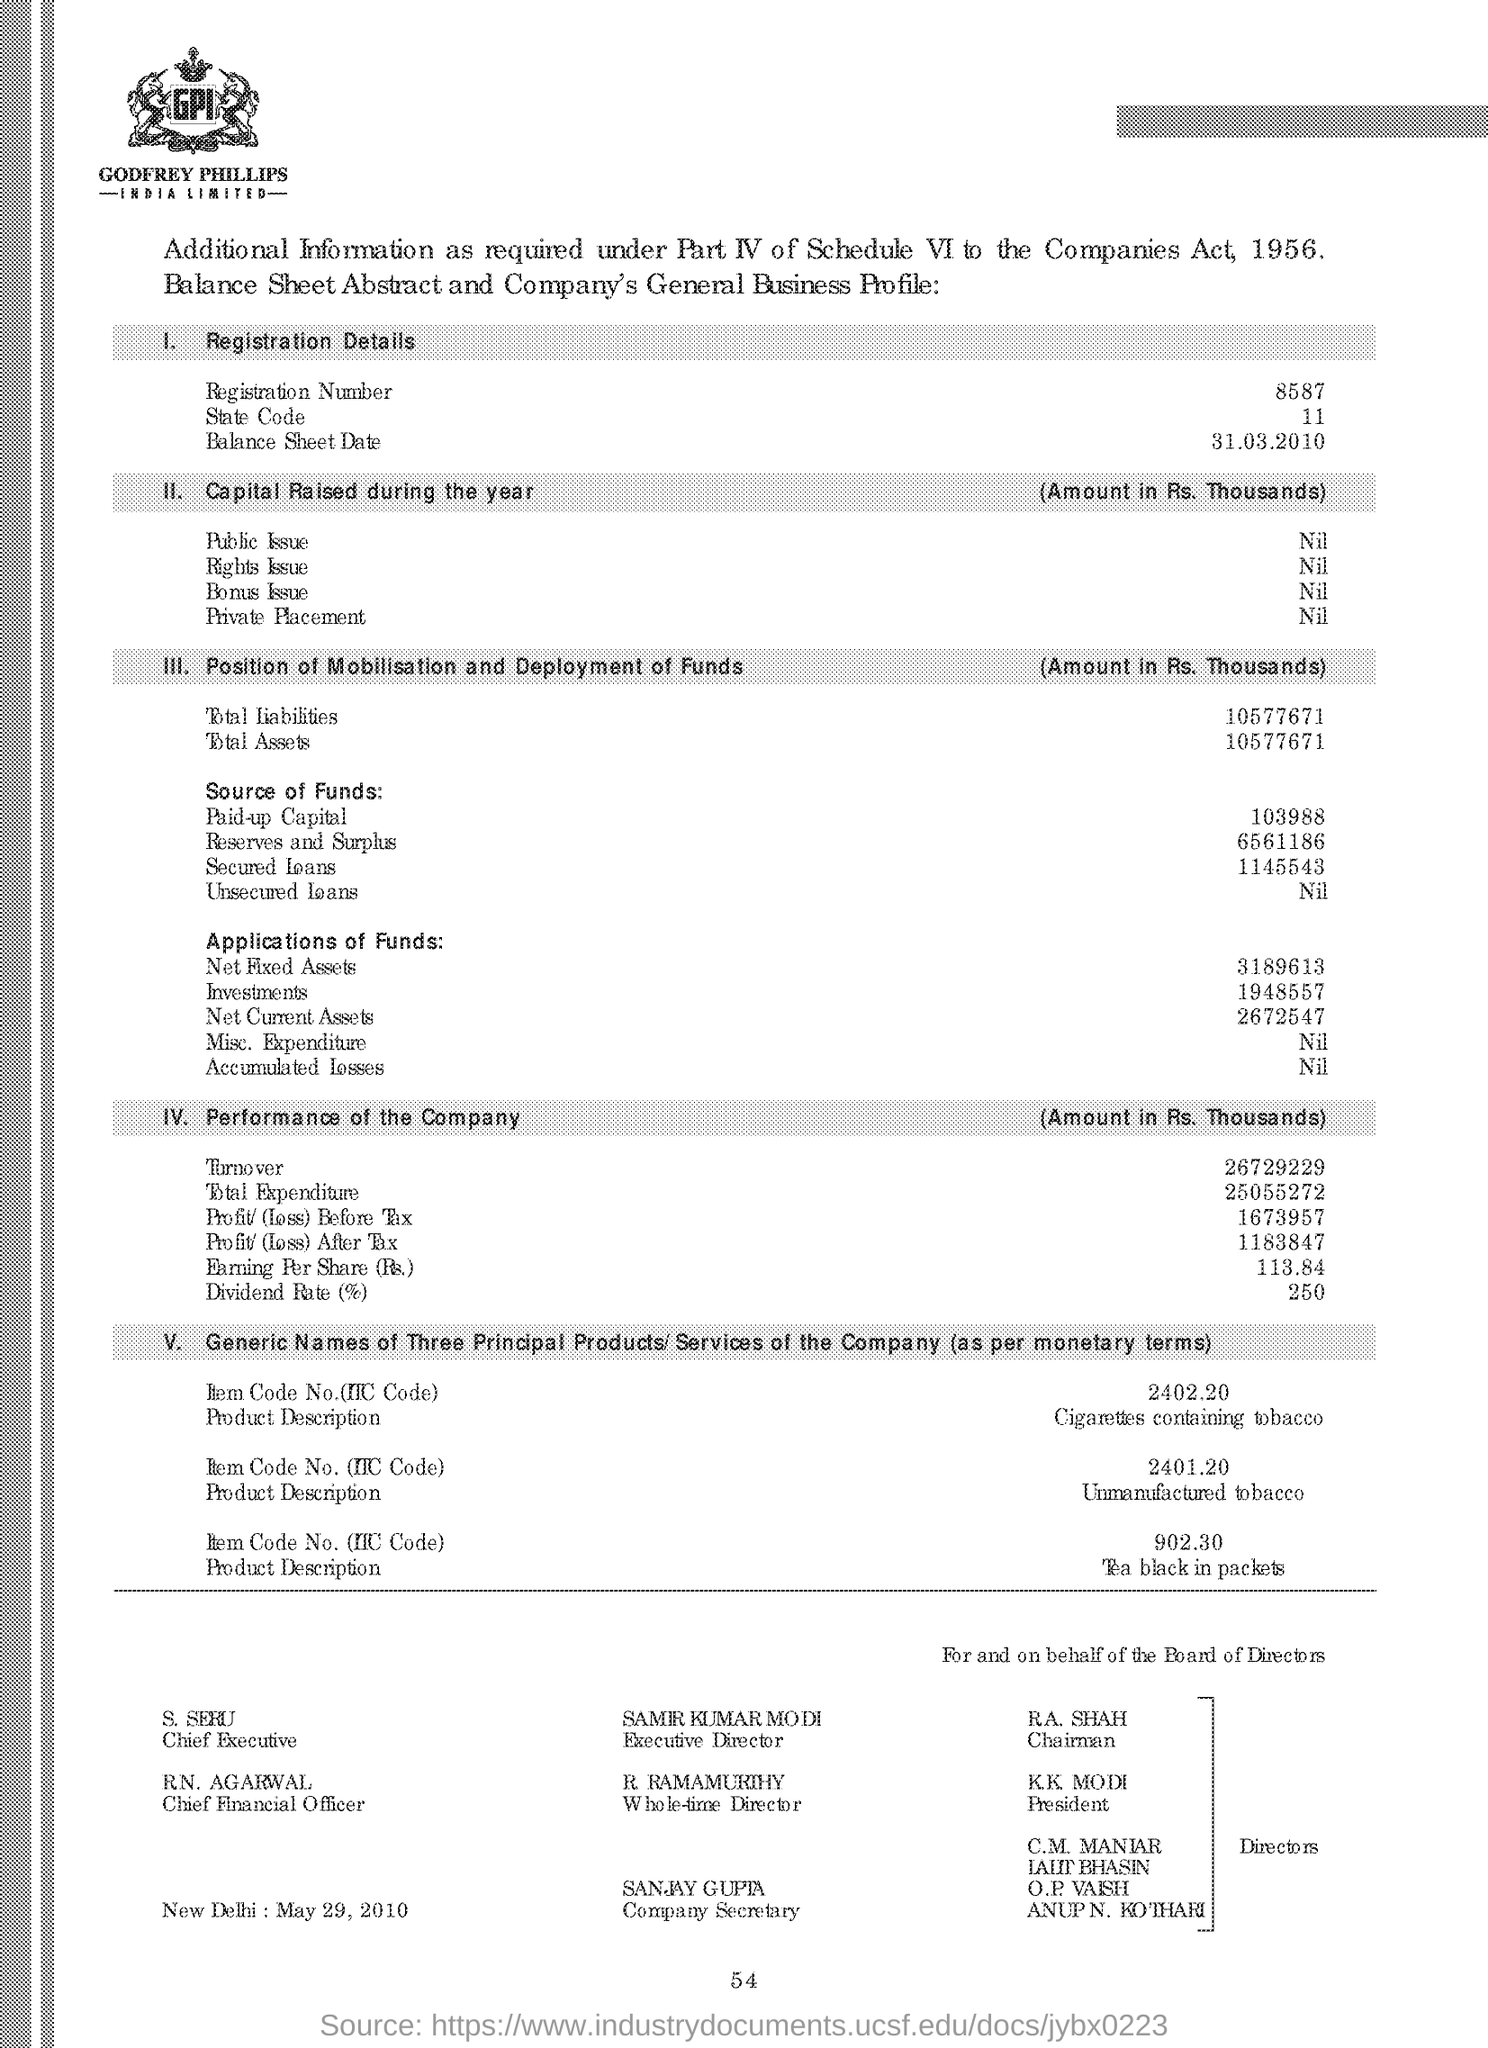What is the Registration Number ?
Ensure brevity in your answer.  8587. What is the State Code?
Offer a terse response. 11. What is the Total amount of Liabilities ?
Provide a short and direct response. 10577671. How much Dividend Rate ?
Your response must be concise. 250. 